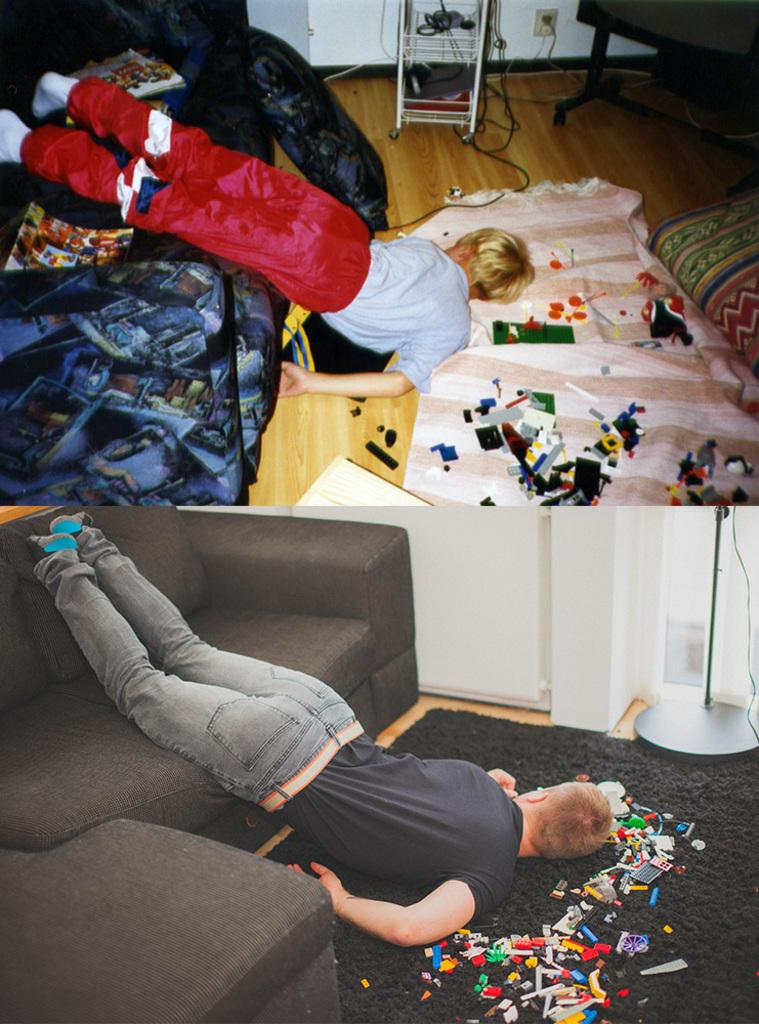How many people are in the image? There are two boys in the image. What are the boys doing in the image? The boys are lying vertically from the sofa to the floor. What can be seen on the floor in the image? There are papers on the floor in the image. What type of magic trick are the boys performing in the image? There is no indication of a magic trick or any magical elements in the image. The boys are simply lying vertically from the sofa to the floor. 